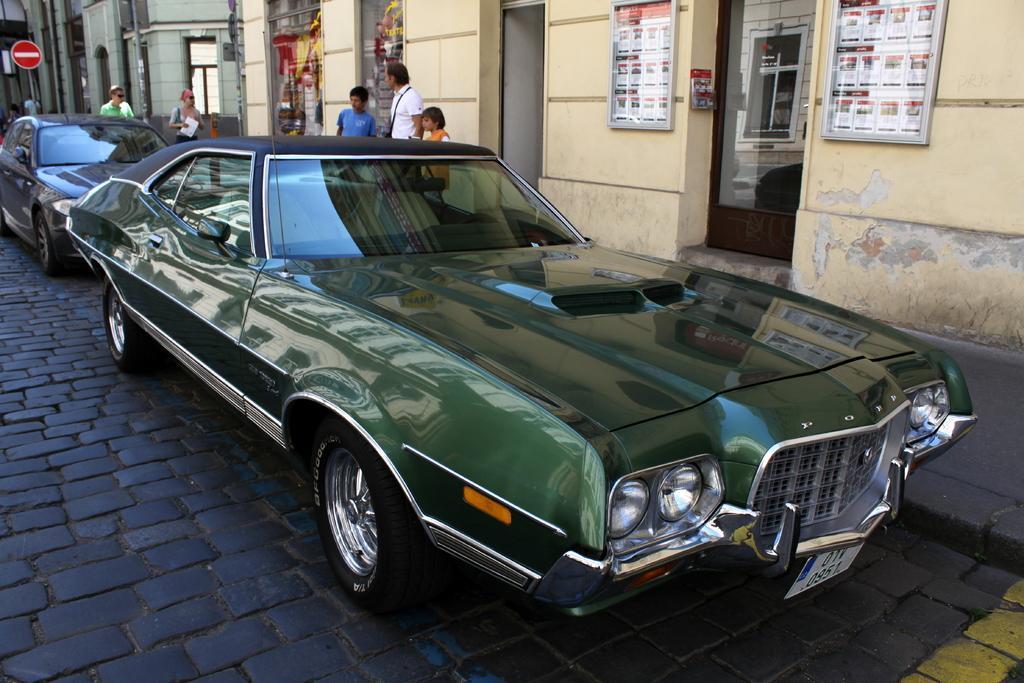Can you describe this image briefly? This picture shows couple of cars parked and few people standing and we see buildings and a sign board and couple of advertisement boards on the wall. 